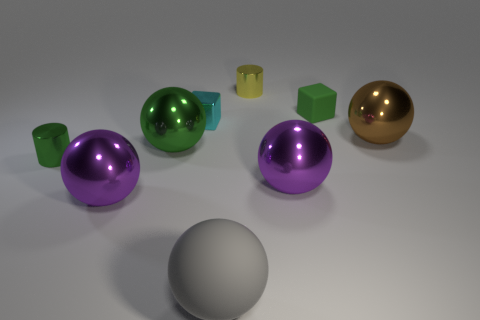Subtract all gray balls. How many balls are left? 4 Subtract all brown spheres. How many spheres are left? 4 Subtract all red spheres. Subtract all brown cylinders. How many spheres are left? 5 Add 1 big gray spheres. How many objects exist? 10 Subtract all blocks. How many objects are left? 7 Subtract 0 brown cylinders. How many objects are left? 9 Subtract all big matte objects. Subtract all small green matte objects. How many objects are left? 7 Add 5 brown objects. How many brown objects are left? 6 Add 4 blocks. How many blocks exist? 6 